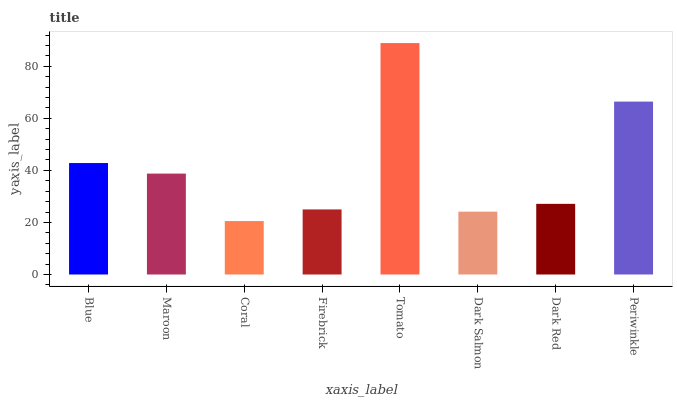Is Maroon the minimum?
Answer yes or no. No. Is Maroon the maximum?
Answer yes or no. No. Is Blue greater than Maroon?
Answer yes or no. Yes. Is Maroon less than Blue?
Answer yes or no. Yes. Is Maroon greater than Blue?
Answer yes or no. No. Is Blue less than Maroon?
Answer yes or no. No. Is Maroon the high median?
Answer yes or no. Yes. Is Dark Red the low median?
Answer yes or no. Yes. Is Coral the high median?
Answer yes or no. No. Is Firebrick the low median?
Answer yes or no. No. 